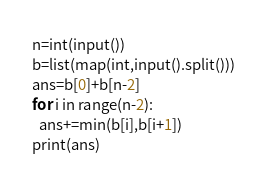Convert code to text. <code><loc_0><loc_0><loc_500><loc_500><_Python_>n=int(input())
b=list(map(int,input().split()))
ans=b[0]+b[n-2]
for i in range(n-2):
  ans+=min(b[i],b[i+1])
print(ans)</code> 